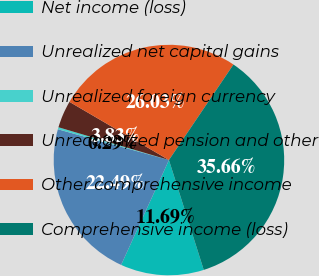Convert chart to OTSL. <chart><loc_0><loc_0><loc_500><loc_500><pie_chart><fcel>Net income (loss)<fcel>Unrealized net capital gains<fcel>Unrealized foreign currency<fcel>Unrecognized pension and other<fcel>Other comprehensive income<fcel>Comprehensive income (loss)<nl><fcel>11.69%<fcel>22.49%<fcel>0.29%<fcel>3.83%<fcel>26.03%<fcel>35.66%<nl></chart> 